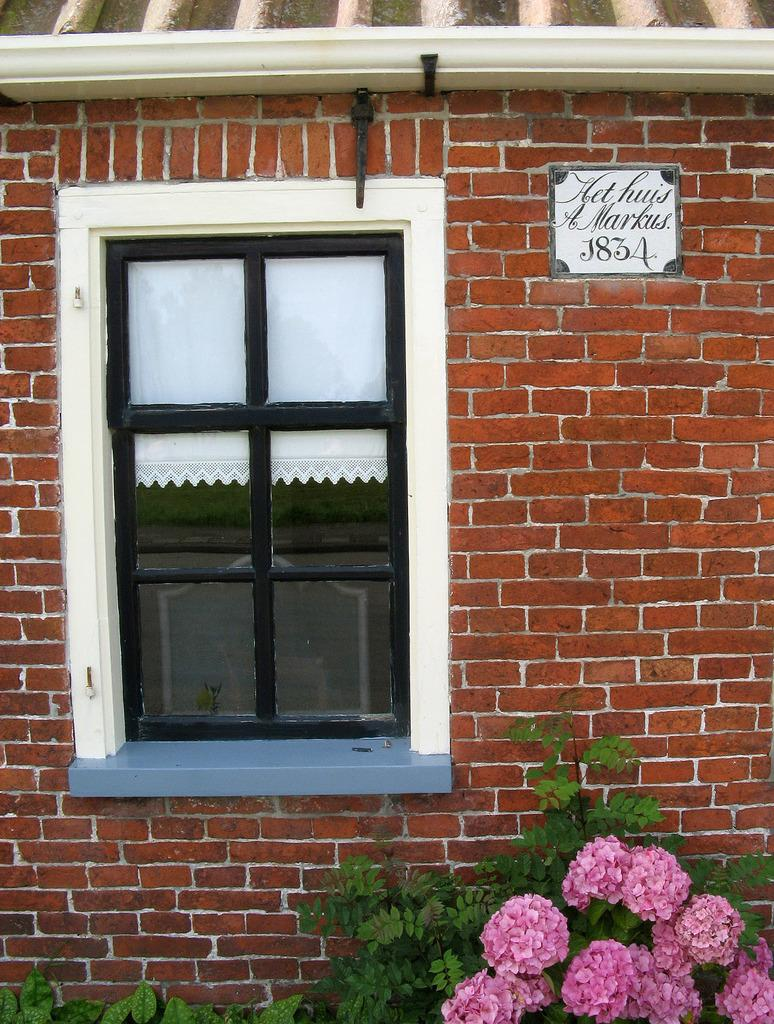What can be seen in the image that provides a view of the outside? There is a window in the image. What is used to cover or decorate the window? There is a curtain associated with the window. What is on the wall in the image? There is a name board on the wall. What type of vegetation is present in the image? There are plants with flowers in the image. What type of wood can be seen in the image? There is no wood present in the image. How many leaves are on the plants with flowers in the image? The provided facts do not specify the number of leaves on the plants with flowers in the image. Are there any insects visible in the image? There is no mention of insects in the provided facts, so we cannot determine if any are present in the image. 